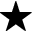<formula> <loc_0><loc_0><loc_500><loc_500>^ { * }</formula> 